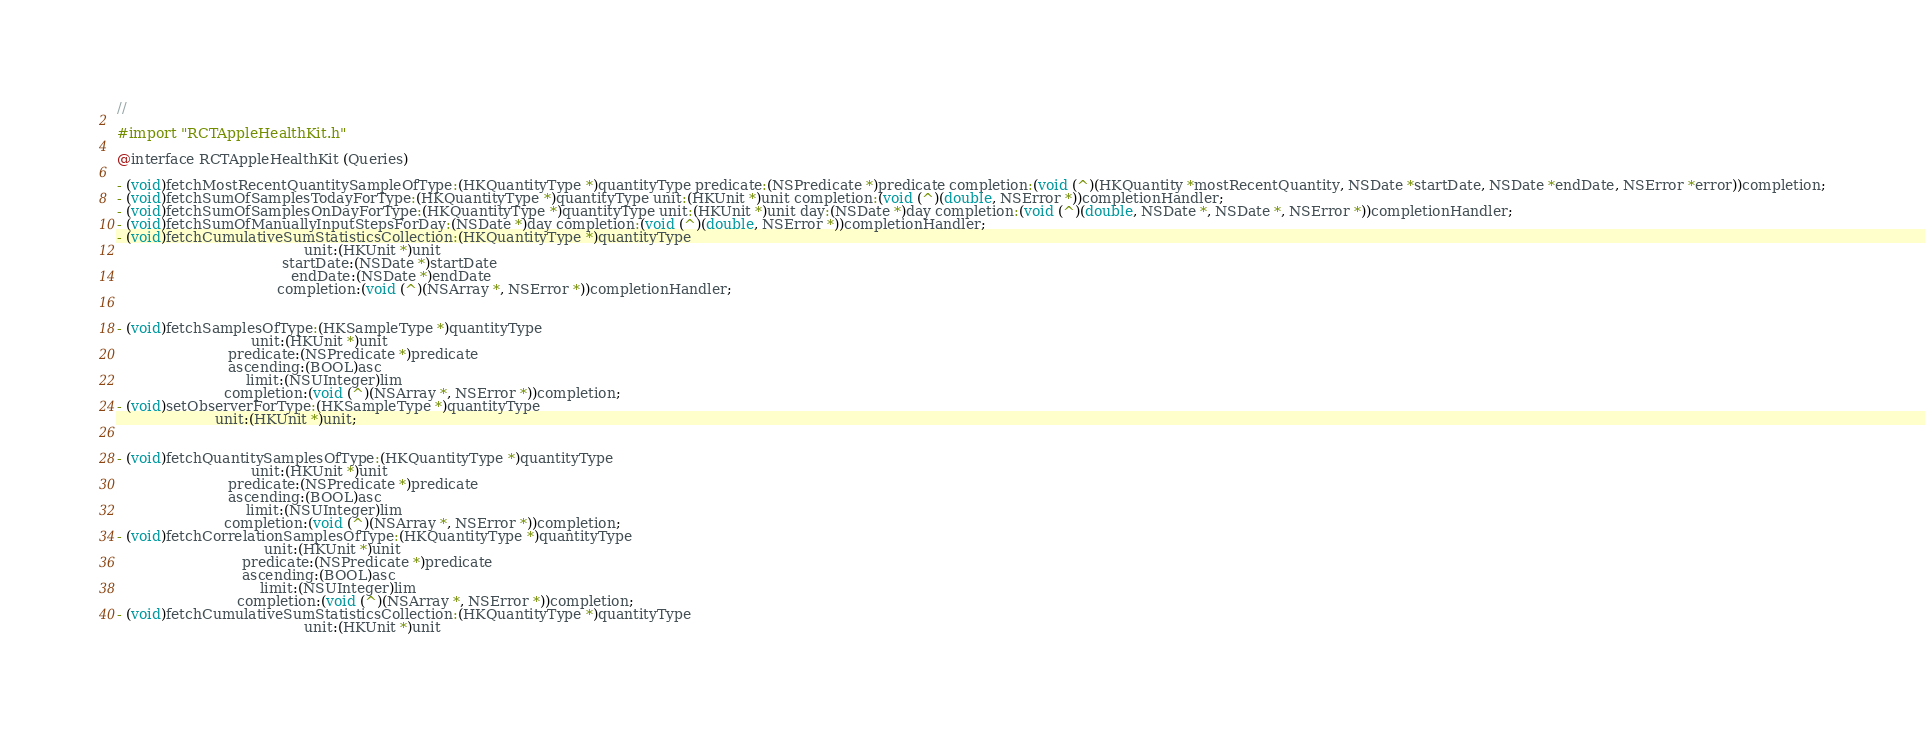<code> <loc_0><loc_0><loc_500><loc_500><_C_>//

#import "RCTAppleHealthKit.h"

@interface RCTAppleHealthKit (Queries)

- (void)fetchMostRecentQuantitySampleOfType:(HKQuantityType *)quantityType predicate:(NSPredicate *)predicate completion:(void (^)(HKQuantity *mostRecentQuantity, NSDate *startDate, NSDate *endDate, NSError *error))completion;
- (void)fetchSumOfSamplesTodayForType:(HKQuantityType *)quantityType unit:(HKUnit *)unit completion:(void (^)(double, NSError *))completionHandler;
- (void)fetchSumOfSamplesOnDayForType:(HKQuantityType *)quantityType unit:(HKUnit *)unit day:(NSDate *)day completion:(void (^)(double, NSDate *, NSDate *, NSError *))completionHandler;
- (void)fetchSumOfManuallyInputStepsForDay:(NSDate *)day completion:(void (^)(double, NSError *))completionHandler;
- (void)fetchCumulativeSumStatisticsCollection:(HKQuantityType *)quantityType
                                          unit:(HKUnit *)unit
                                     startDate:(NSDate *)startDate
                                       endDate:(NSDate *)endDate
                                    completion:(void (^)(NSArray *, NSError *))completionHandler;


- (void)fetchSamplesOfType:(HKSampleType *)quantityType
                              unit:(HKUnit *)unit
                         predicate:(NSPredicate *)predicate
                         ascending:(BOOL)asc
                             limit:(NSUInteger)lim
                        completion:(void (^)(NSArray *, NSError *))completion;
- (void)setObserverForType:(HKSampleType *)quantityType
                      unit:(HKUnit *)unit;


- (void)fetchQuantitySamplesOfType:(HKQuantityType *)quantityType
                              unit:(HKUnit *)unit
                         predicate:(NSPredicate *)predicate
                         ascending:(BOOL)asc
                             limit:(NSUInteger)lim
                        completion:(void (^)(NSArray *, NSError *))completion;
- (void)fetchCorrelationSamplesOfType:(HKQuantityType *)quantityType
                                 unit:(HKUnit *)unit
                            predicate:(NSPredicate *)predicate
                            ascending:(BOOL)asc
                                limit:(NSUInteger)lim
                           completion:(void (^)(NSArray *, NSError *))completion;
- (void)fetchCumulativeSumStatisticsCollection:(HKQuantityType *)quantityType
                                          unit:(HKUnit *)unit</code> 